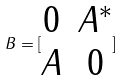Convert formula to latex. <formula><loc_0><loc_0><loc_500><loc_500>B = [ \begin{matrix} 0 & A ^ { * } \\ A & 0 \end{matrix} ]</formula> 